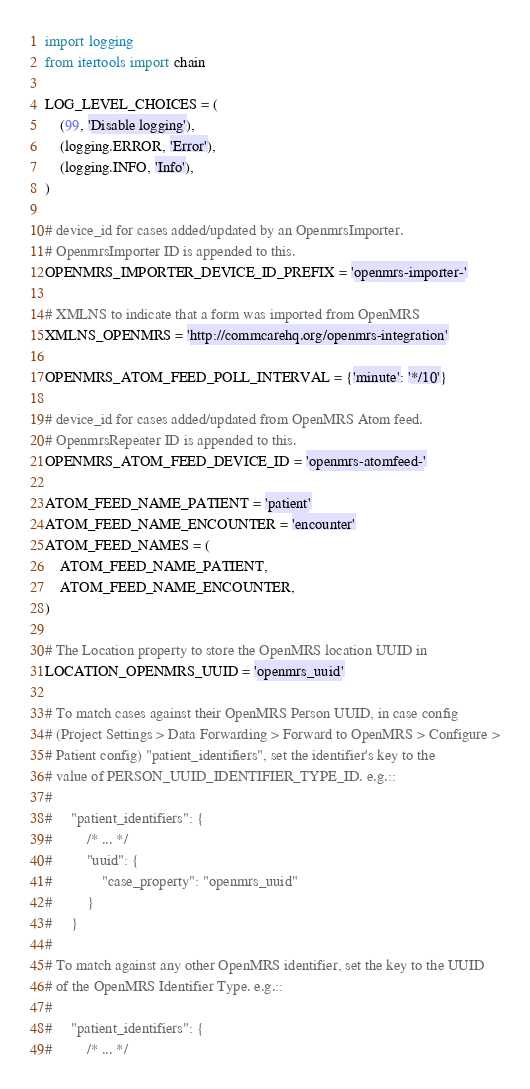<code> <loc_0><loc_0><loc_500><loc_500><_Python_>import logging
from itertools import chain

LOG_LEVEL_CHOICES = (
    (99, 'Disable logging'),
    (logging.ERROR, 'Error'),
    (logging.INFO, 'Info'),
)

# device_id for cases added/updated by an OpenmrsImporter.
# OpenmrsImporter ID is appended to this.
OPENMRS_IMPORTER_DEVICE_ID_PREFIX = 'openmrs-importer-'

# XMLNS to indicate that a form was imported from OpenMRS
XMLNS_OPENMRS = 'http://commcarehq.org/openmrs-integration'

OPENMRS_ATOM_FEED_POLL_INTERVAL = {'minute': '*/10'}

# device_id for cases added/updated from OpenMRS Atom feed.
# OpenmrsRepeater ID is appended to this.
OPENMRS_ATOM_FEED_DEVICE_ID = 'openmrs-atomfeed-'

ATOM_FEED_NAME_PATIENT = 'patient'
ATOM_FEED_NAME_ENCOUNTER = 'encounter'
ATOM_FEED_NAMES = (
    ATOM_FEED_NAME_PATIENT,
    ATOM_FEED_NAME_ENCOUNTER,
)

# The Location property to store the OpenMRS location UUID in
LOCATION_OPENMRS_UUID = 'openmrs_uuid'

# To match cases against their OpenMRS Person UUID, in case config
# (Project Settings > Data Forwarding > Forward to OpenMRS > Configure >
# Patient config) "patient_identifiers", set the identifier's key to the
# value of PERSON_UUID_IDENTIFIER_TYPE_ID. e.g.::
#
#     "patient_identifiers": {
#         /* ... */
#         "uuid": {
#             "case_property": "openmrs_uuid"
#         }
#     }
#
# To match against any other OpenMRS identifier, set the key to the UUID
# of the OpenMRS Identifier Type. e.g.::
#
#     "patient_identifiers": {
#         /* ... */</code> 